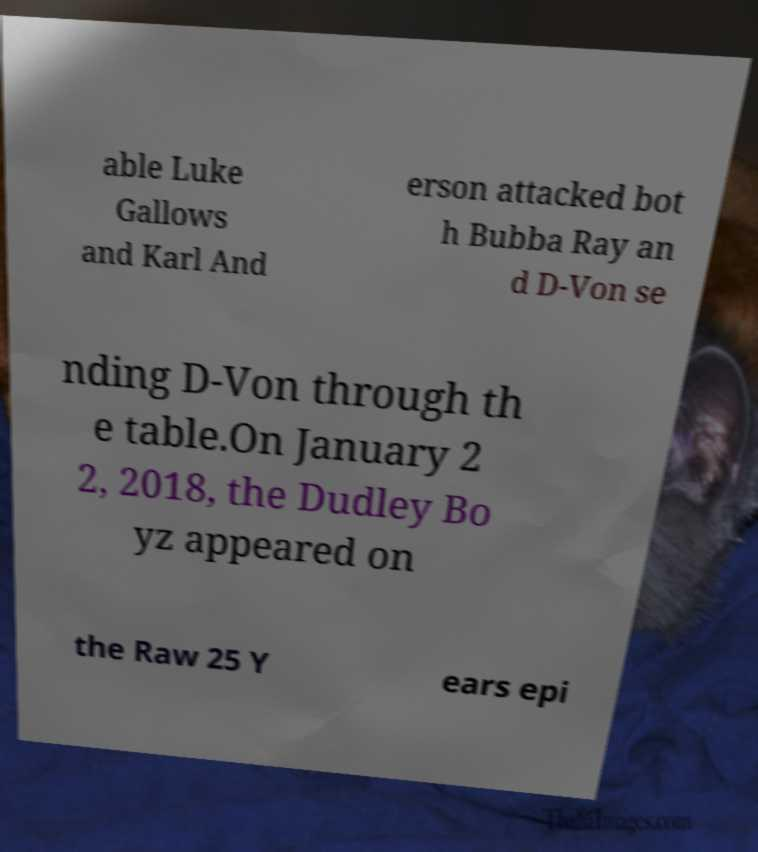Can you accurately transcribe the text from the provided image for me? able Luke Gallows and Karl And erson attacked bot h Bubba Ray an d D-Von se nding D-Von through th e table.On January 2 2, 2018, the Dudley Bo yz appeared on the Raw 25 Y ears epi 